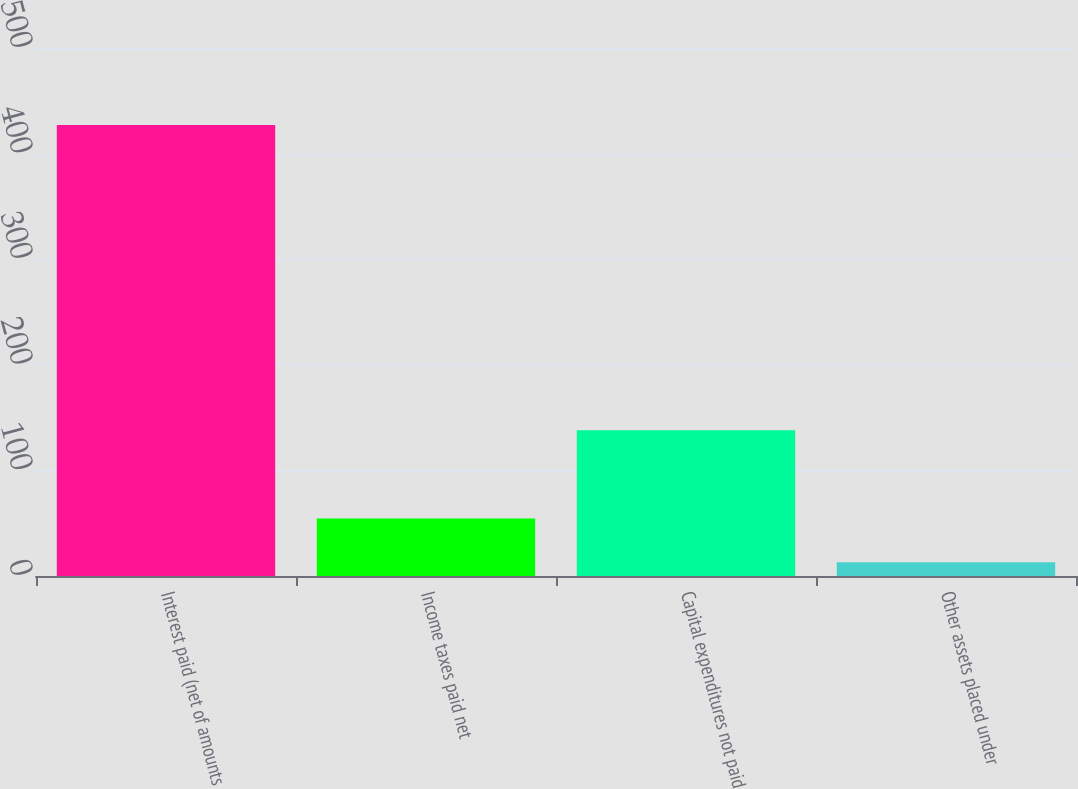Convert chart. <chart><loc_0><loc_0><loc_500><loc_500><bar_chart><fcel>Interest paid (net of amounts<fcel>Income taxes paid net<fcel>Capital expenditures not paid<fcel>Other assets placed under<nl><fcel>427<fcel>54.4<fcel>138<fcel>13<nl></chart> 